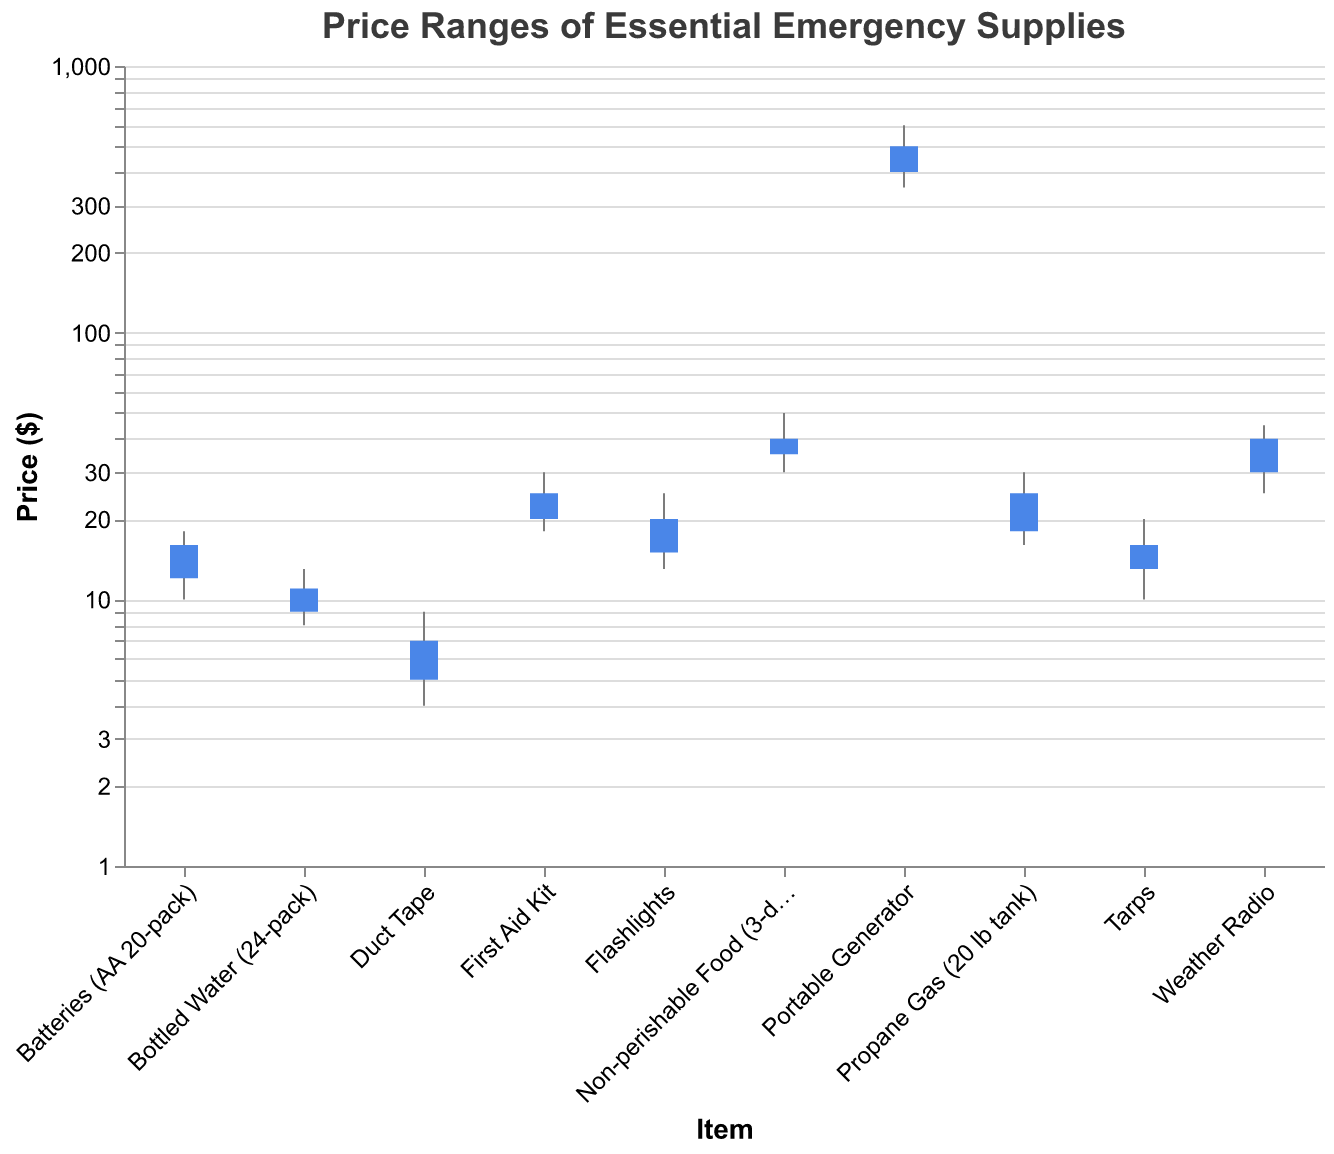What is the title of the figure? The title of the figure is located at the top, which summarizes the content of the chart.
Answer: Price Ranges of Essential Emergency Supplies Which item has the highest price range? To find the item with the highest price range, we need to compare the High and Low values for each item and identify the largest difference. The Portable Generator ranges from $349.99 (Low) to $599.99 (High), which is a range of $250.00.
Answer: Portable Generator What is the price difference between the opening and closing prices for Flashlights? The opening price for Flashlights is $14.99, and the closing price is $19.99. Subtract the opening price from the closing price: $19.99 - $14.99 = $5.00.
Answer: $5.00 Which item had the highest opening price? We compare the 'Open' prices of all items. The Portable Generator has the highest opening price at $399.99.
Answer: Portable Generator What is the closing price for Non-perishable Food (3-day supply)? The closing price for Non-perishable Food (3-day supply) is listed as $39.99.
Answer: $39.99 Which item experienced the lowest price during peak storm season? By reviewing the 'Low' prices in the chart, we see that Duct Tape has the lowest price at $3.99.
Answer: Duct Tape How do the open and close prices for Tarps compare? For Tarps, the opening price is $12.99, and the closing price is $15.99. The closing price is higher than the opening price by $3.00 ($15.99 - $12.99).
Answer: The closing price is $3.00 higher Which items had their closing prices higher than their opening prices? Compare the closing and opening prices for each item. The items with closing prices higher than their opening prices are Bottled Water (24-pack), Flashlights, Batteries (AA 20-pack), First Aid Kit, Non-perishable Food (3-day supply), Portable Generator, Weather Radio, and Tarps.
Answer: 8 items (Bottled Water (24-pack), Flashlights, Batteries (AA 20-pack), First Aid Kit, Non-perishable Food (3-day supply), Portable Generator, Weather Radio, and Tarps) What is the average high price of the items? Sum the high prices of all items and divide by the number of items: (12.99 + 24.99 + 17.99 + 29.99 + 49.99 + 599.99 + 44.99 + 19.99 + 8.99 + 29.99) / 10 = 1839.9 / 10 = 183.99.
Answer: $183.99 